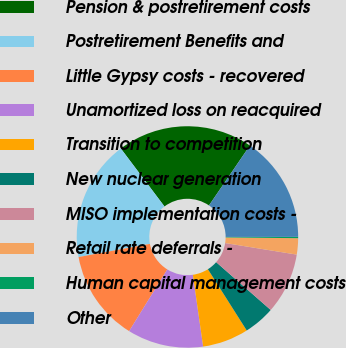Convert chart to OTSL. <chart><loc_0><loc_0><loc_500><loc_500><pie_chart><fcel>Pension & postretirement costs<fcel>Postretirement Benefits and<fcel>Little Gypsy costs - recovered<fcel>Unamortized loss on reacquired<fcel>Transition to competition<fcel>New nuclear generation<fcel>MISO implementation costs -<fcel>Retail rate deferrals -<fcel>Human capital management costs<fcel>Other<nl><fcel>19.81%<fcel>17.63%<fcel>13.27%<fcel>11.09%<fcel>6.73%<fcel>4.55%<fcel>8.91%<fcel>2.37%<fcel>0.19%<fcel>15.45%<nl></chart> 